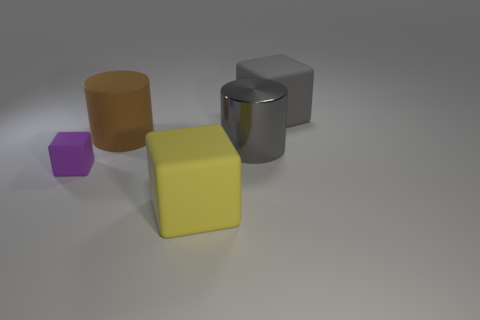Add 1 large purple things. How many objects exist? 6 Subtract all cubes. How many objects are left? 2 Subtract 0 green blocks. How many objects are left? 5 Subtract all large yellow things. Subtract all brown rubber cylinders. How many objects are left? 3 Add 4 brown objects. How many brown objects are left? 5 Add 1 big yellow objects. How many big yellow objects exist? 2 